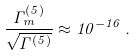Convert formula to latex. <formula><loc_0><loc_0><loc_500><loc_500>\frac { \Gamma _ { m } ^ { ( 5 ) } } { \sqrt { \Gamma ^ { ( 5 ) } } } \approx 1 0 ^ { - 1 6 } \, .</formula> 